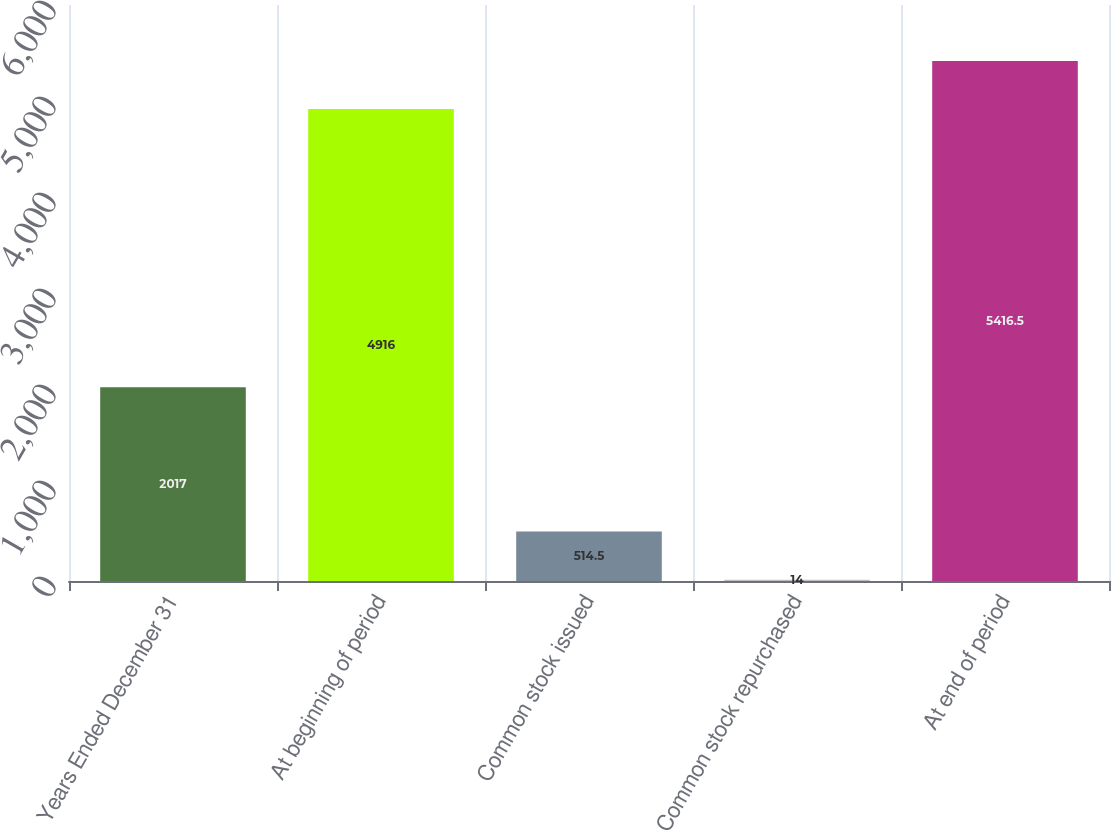Convert chart to OTSL. <chart><loc_0><loc_0><loc_500><loc_500><bar_chart><fcel>Years Ended December 31<fcel>At beginning of period<fcel>Common stock issued<fcel>Common stock repurchased<fcel>At end of period<nl><fcel>2017<fcel>4916<fcel>514.5<fcel>14<fcel>5416.5<nl></chart> 